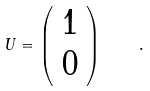Convert formula to latex. <formula><loc_0><loc_0><loc_500><loc_500>U = \left ( \begin{array} { c } 1 \\ 0 \end{array} \right ) \quad .</formula> 